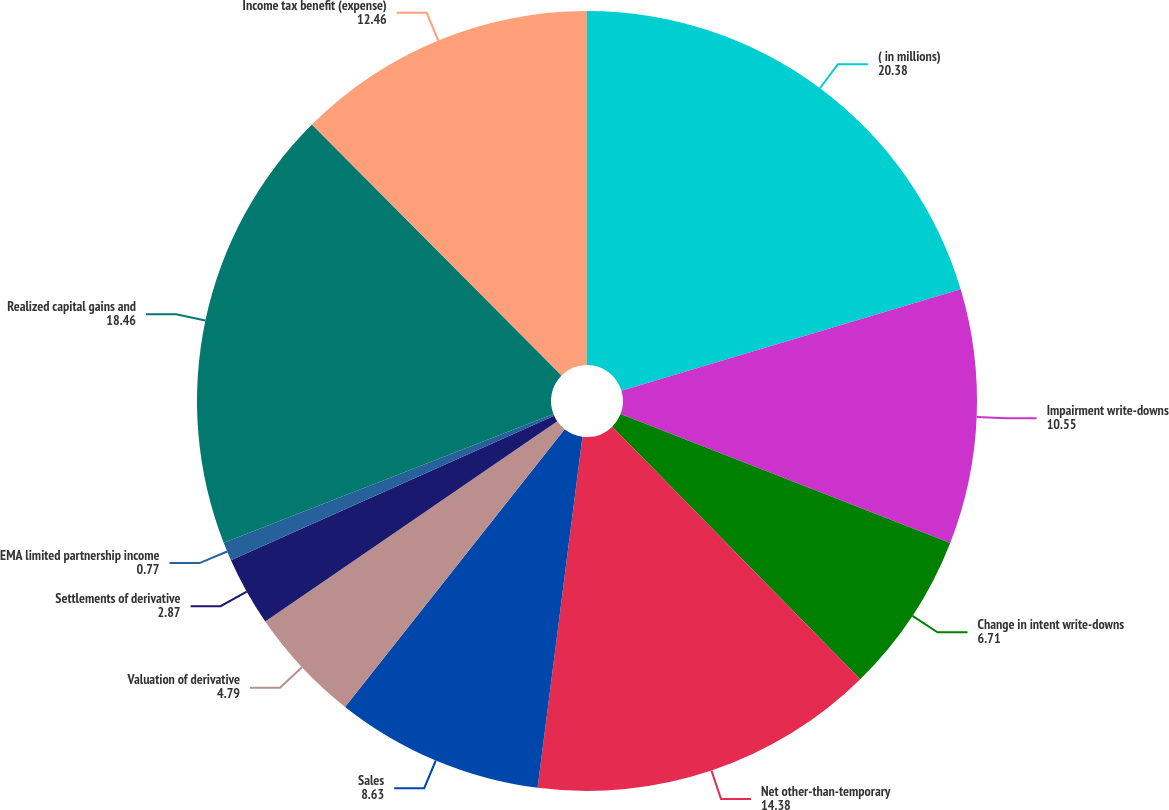Convert chart to OTSL. <chart><loc_0><loc_0><loc_500><loc_500><pie_chart><fcel>( in millions)<fcel>Impairment write-downs<fcel>Change in intent write-downs<fcel>Net other-than-temporary<fcel>Sales<fcel>Valuation of derivative<fcel>Settlements of derivative<fcel>EMA limited partnership income<fcel>Realized capital gains and<fcel>Income tax benefit (expense)<nl><fcel>20.38%<fcel>10.55%<fcel>6.71%<fcel>14.38%<fcel>8.63%<fcel>4.79%<fcel>2.87%<fcel>0.77%<fcel>18.46%<fcel>12.46%<nl></chart> 